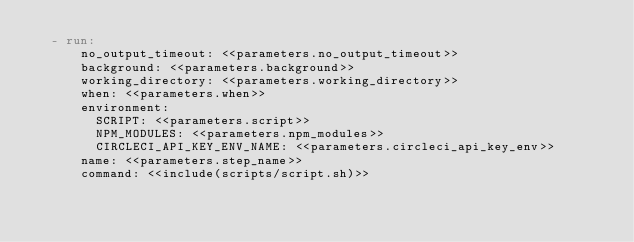<code> <loc_0><loc_0><loc_500><loc_500><_YAML_>  - run:
      no_output_timeout: <<parameters.no_output_timeout>>
      background: <<parameters.background>>
      working_directory: <<parameters.working_directory>>
      when: <<parameters.when>>
      environment:
        SCRIPT: <<parameters.script>>
        NPM_MODULES: <<parameters.npm_modules>>
        CIRCLECI_API_KEY_ENV_NAME: <<parameters.circleci_api_key_env>>
      name: <<parameters.step_name>>
      command: <<include(scripts/script.sh)>>
</code> 